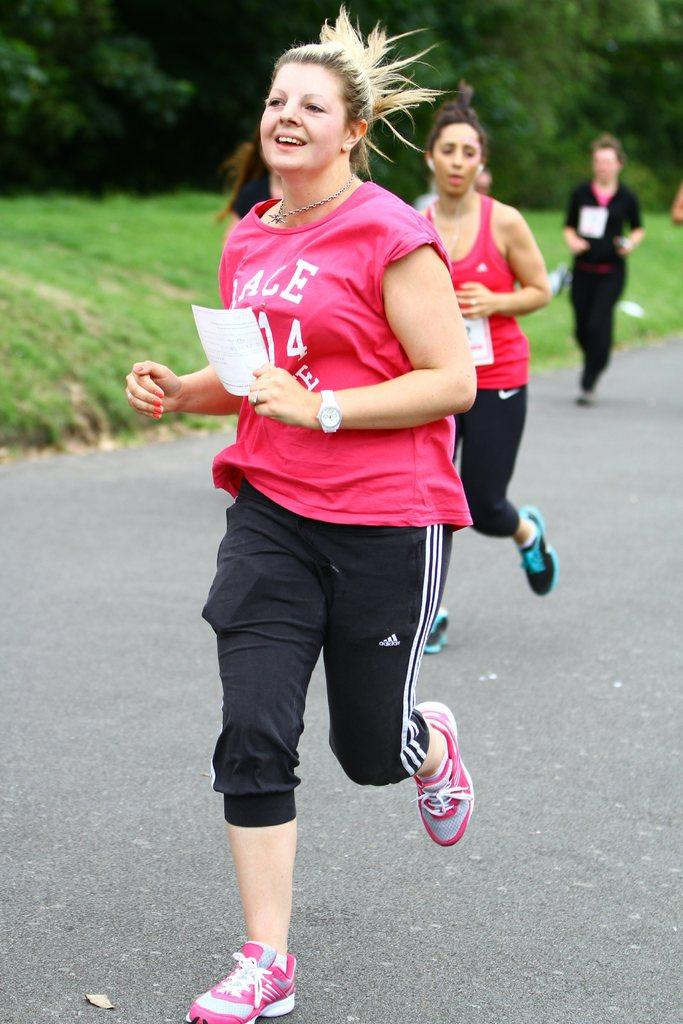Who is the main subject in the image? There is a lady in the center of the image. What is the lady holding in her hand? The lady is holding a paper in her hand. What is the lady doing in the image? The lady appears to be running. What can be seen in the background of the image? There are people and greenery in the background of the image. What type of books can be found in the library depicted in the image? There is no library present in the image, so it is not possible to determine what type of books might be found there. 